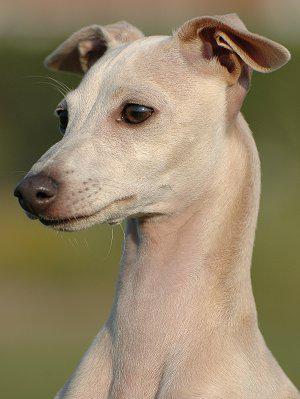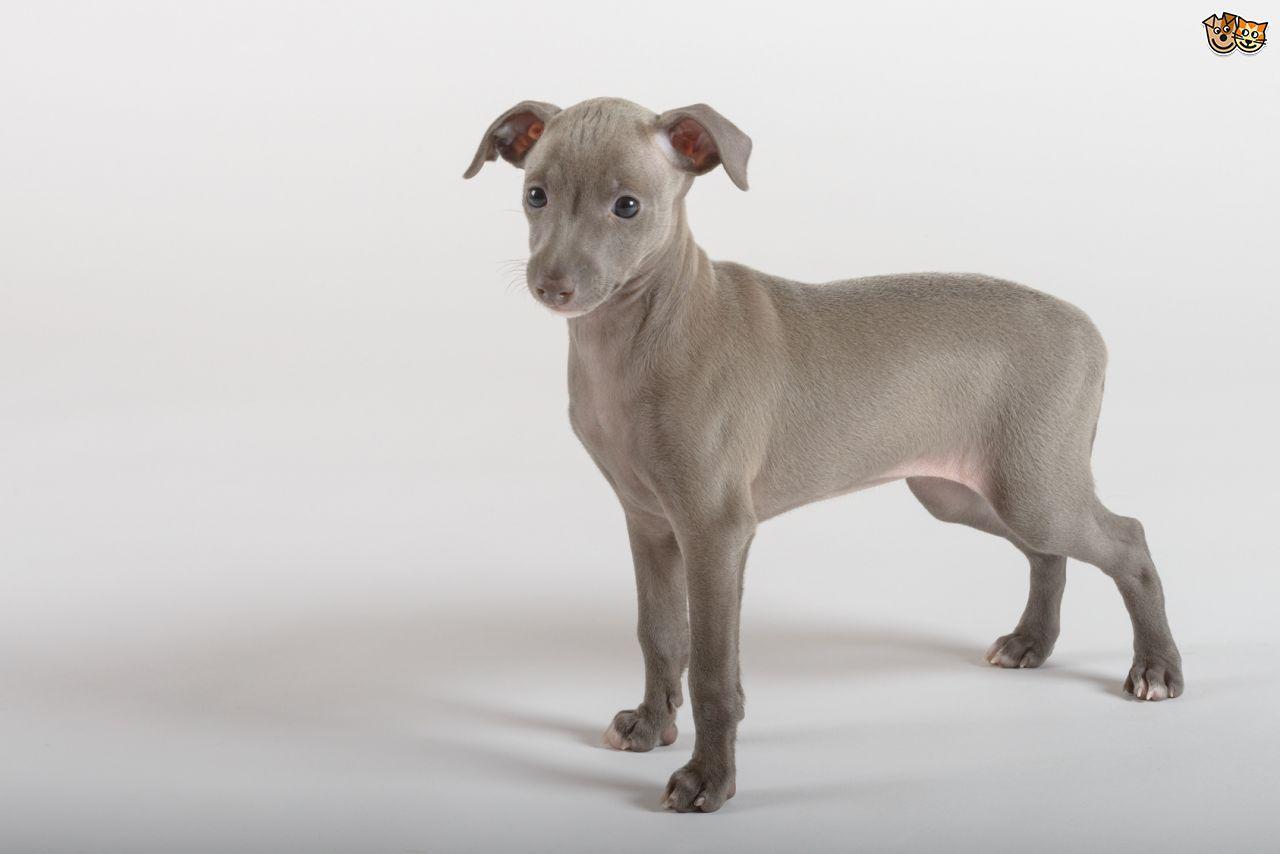The first image is the image on the left, the second image is the image on the right. Analyze the images presented: Is the assertion "One of the dogs has a collar around its neck." valid? Answer yes or no. No. The first image is the image on the left, the second image is the image on the right. Assess this claim about the two images: "An image shows a dog with its tongue sticking out.". Correct or not? Answer yes or no. No. 